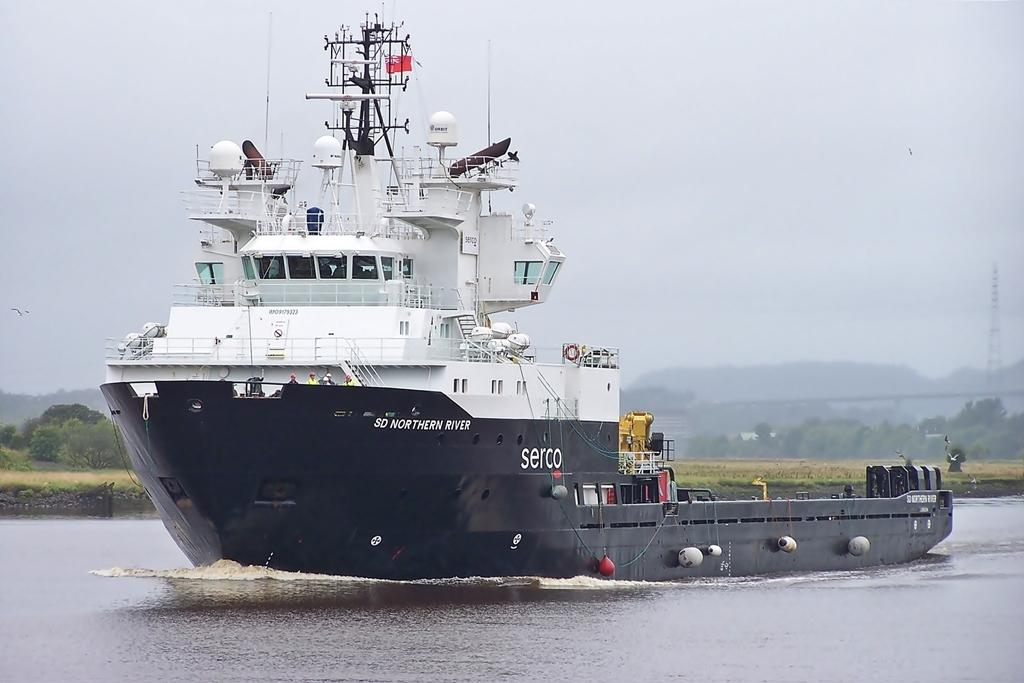What is the main subject in the center of the image? There is a ship in the center of the image. What can be seen at the bottom of the image? There is water visible at the bottom of the image. What type of landscape can be seen in the background of the image? There are trees and a hill in the background of the image. What is visible in the sky in the background of the image? The sky is visible in the background of the image. What type of music can be heard coming from the ship in the image? There is no indication of music or any sounds in the image, so it's not possible to determine what, if any, music might be heard. 